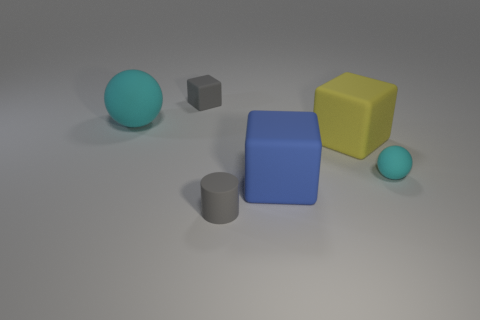Is there a matte cube behind the cyan matte thing on the right side of the small gray matte cylinder?
Ensure brevity in your answer.  Yes. There is a cyan rubber sphere on the left side of the small ball; is its size the same as the yellow matte thing that is right of the tiny gray block?
Keep it short and to the point. Yes. How many small objects are matte cylinders or balls?
Ensure brevity in your answer.  2. The large cube that is in front of the big yellow object that is behind the tiny rubber sphere is made of what material?
Your response must be concise. Rubber. There is a rubber thing that is the same color as the big ball; what shape is it?
Your response must be concise. Sphere. Is there another small yellow cube that has the same material as the tiny cube?
Offer a very short reply. No. Is the small cyan thing made of the same material as the big blue block that is in front of the large yellow cube?
Offer a very short reply. Yes. There is a ball that is the same size as the yellow rubber cube; what is its color?
Provide a succinct answer. Cyan. There is a cyan thing to the right of the cube in front of the tiny matte sphere; what size is it?
Provide a succinct answer. Small. Do the small matte cube and the big object to the right of the blue matte thing have the same color?
Your response must be concise. No. 